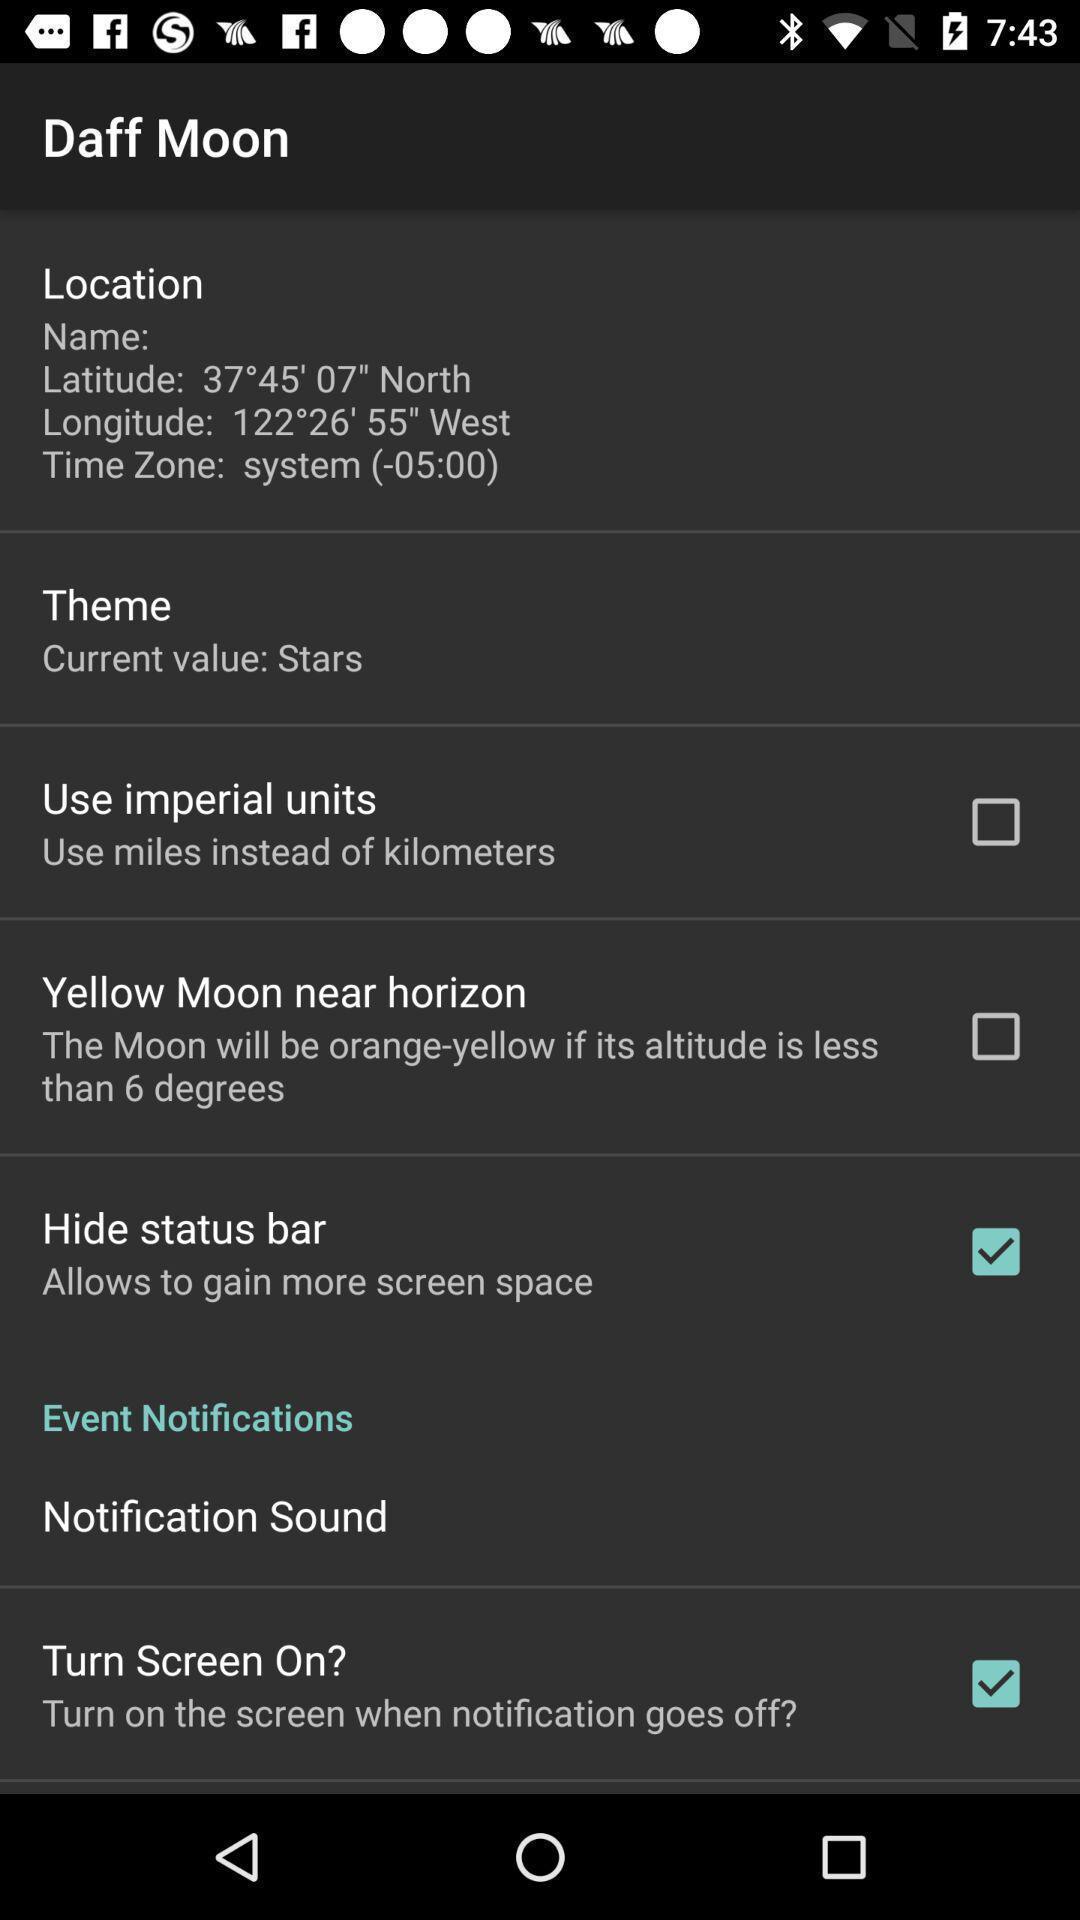Provide a detailed account of this screenshot. Settings page with list of options in the astronomy app. 